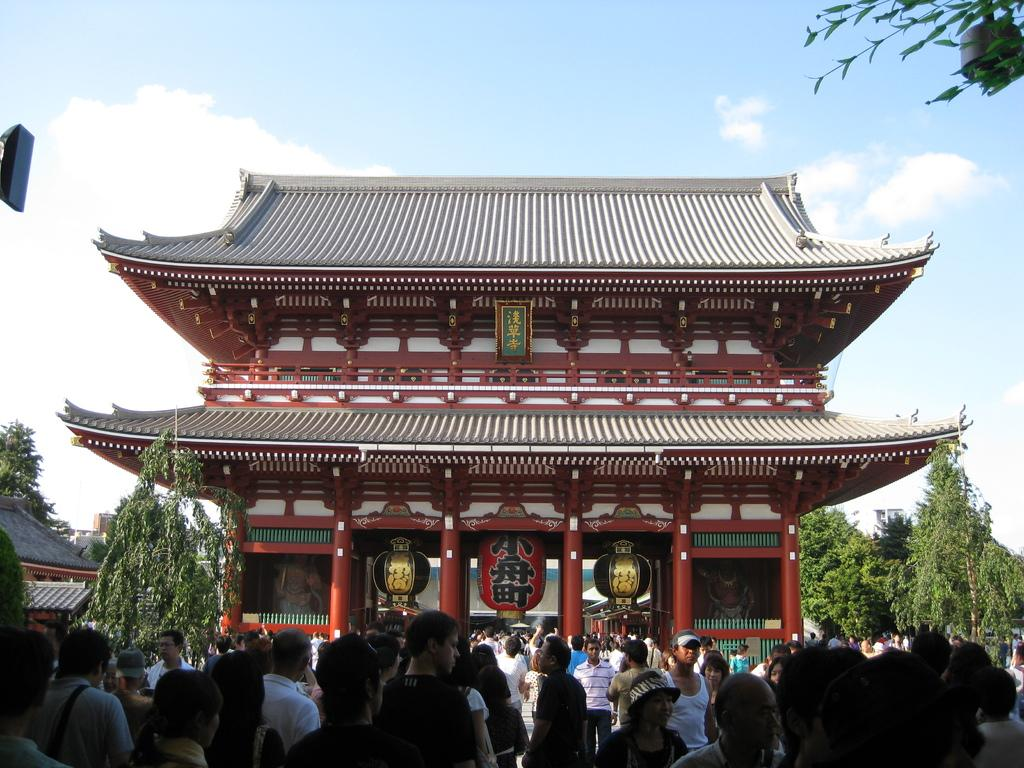What can be seen at the bottom of the image? There are many people standing at the bottom of the image. What structure is located in the middle of the image? There is a house in the middle of the image. What type of vegetation is on either side of the house? There are trees on either side of the house. What is visible at the top of the image? The sky is visible at the top of the image. How many people are jumping in the image? There is no indication of anyone jumping in the image; people are standing at the bottom. What type of cloth is draped over the house in the image? There is no cloth draped over the house in the image; it is a regular house with trees on either side. 